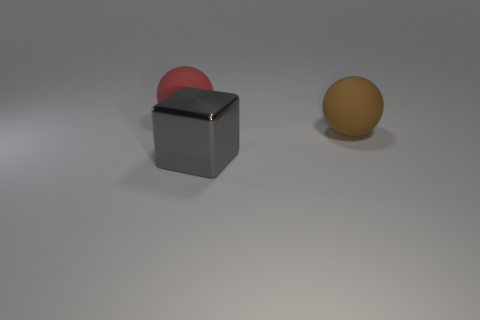Are there more gray cubes than gray matte spheres? yes 